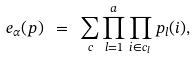Convert formula to latex. <formula><loc_0><loc_0><loc_500><loc_500>e _ { \alpha } ( p ) \ = \ \sum _ { c } \prod _ { l = 1 } ^ { a } \prod _ { i \in c _ { l } } p _ { l } ( i ) ,</formula> 